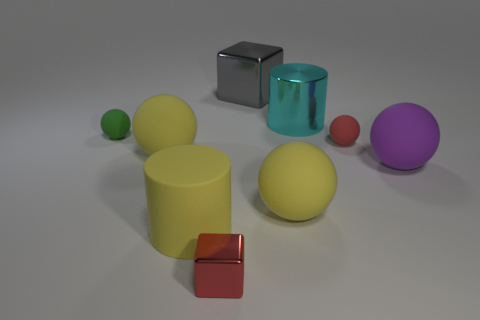Subtract all green spheres. How many spheres are left? 4 Subtract 1 spheres. How many spheres are left? 4 Subtract all green spheres. How many spheres are left? 4 Subtract all cyan balls. Subtract all red cubes. How many balls are left? 5 Add 1 large gray things. How many objects exist? 10 Subtract all cylinders. How many objects are left? 7 Add 5 big gray cylinders. How many big gray cylinders exist? 5 Subtract 0 blue cylinders. How many objects are left? 9 Subtract all cyan rubber things. Subtract all tiny green rubber things. How many objects are left? 8 Add 6 yellow objects. How many yellow objects are left? 9 